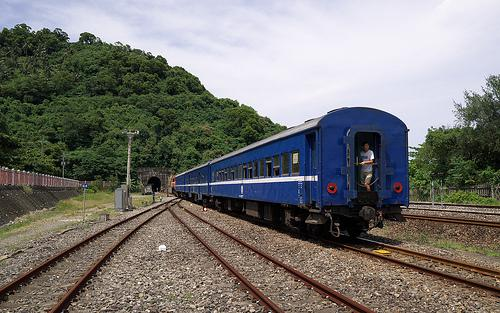Question: what vehicle is shown?
Choices:
A. Boat.
B. Car.
C. Train.
D. Plane.
Answer with the letter. Answer: C Question: where is the train?
Choices:
A. At the station.
B. In the city.
C. In the country side.
D. On the tracks.
Answer with the letter. Answer: D Question: who is on the train?
Choices:
A. Child.
B. Teenager.
C. Mother.
D. Man.
Answer with the letter. Answer: D Question: where is train headed?
Choices:
A. New York City.
B. Tunnel.
C. West.
D. Las Vegas.
Answer with the letter. Answer: B Question: where is the man?
Choices:
A. On the boat.
B. In the car.
C. Last car of train.
D. On the roof.
Answer with the letter. Answer: C 